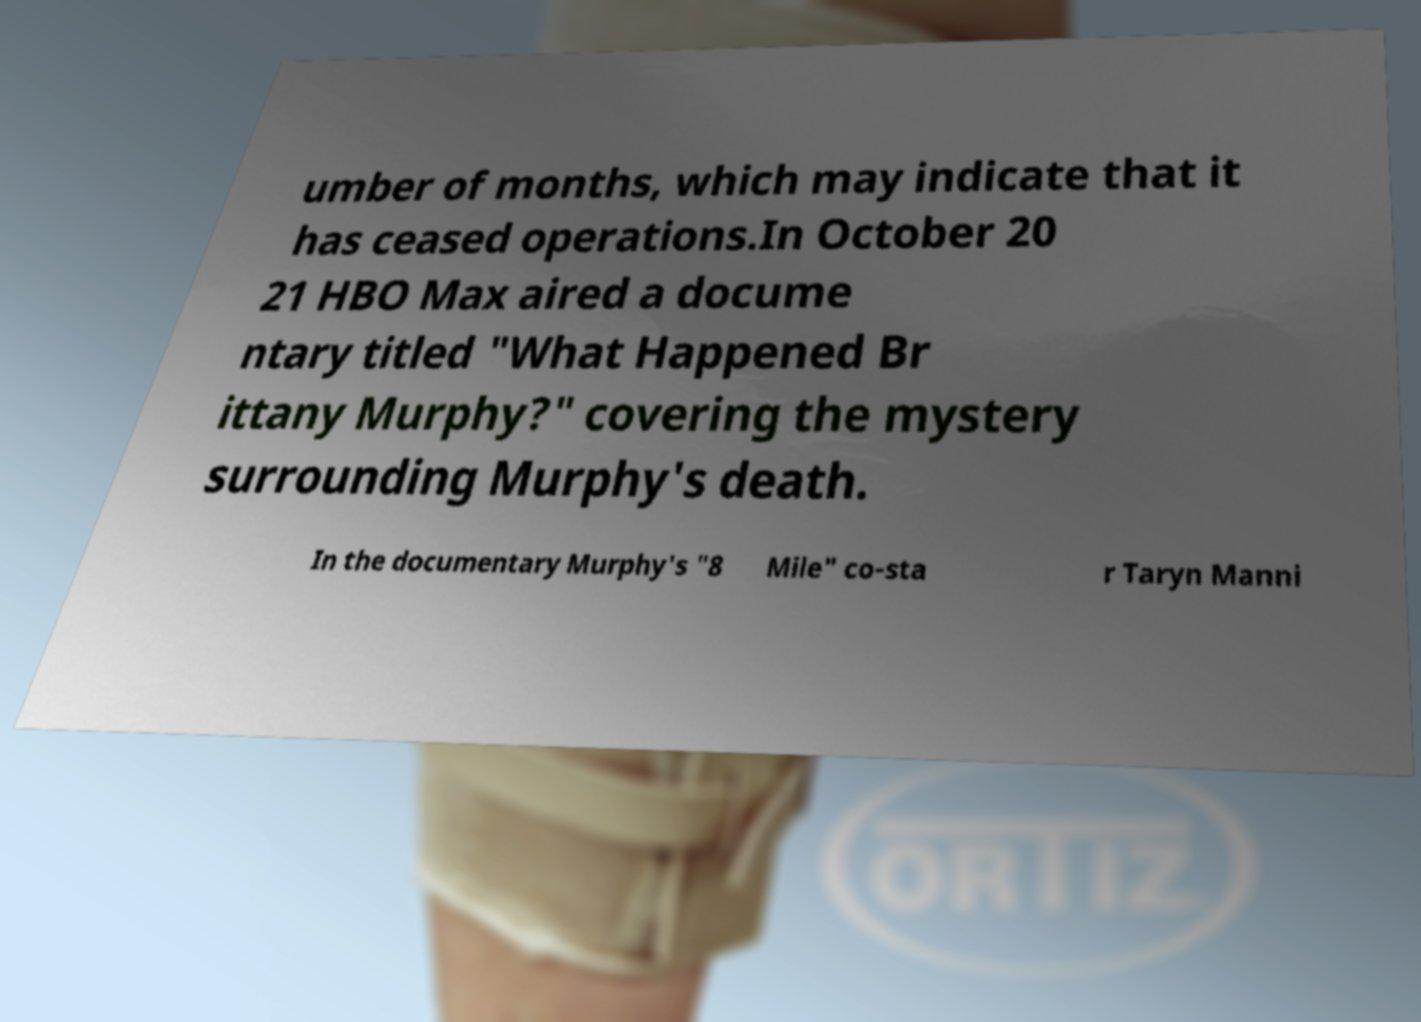Can you accurately transcribe the text from the provided image for me? umber of months, which may indicate that it has ceased operations.In October 20 21 HBO Max aired a docume ntary titled "What Happened Br ittany Murphy?" covering the mystery surrounding Murphy's death. In the documentary Murphy's "8 Mile" co-sta r Taryn Manni 